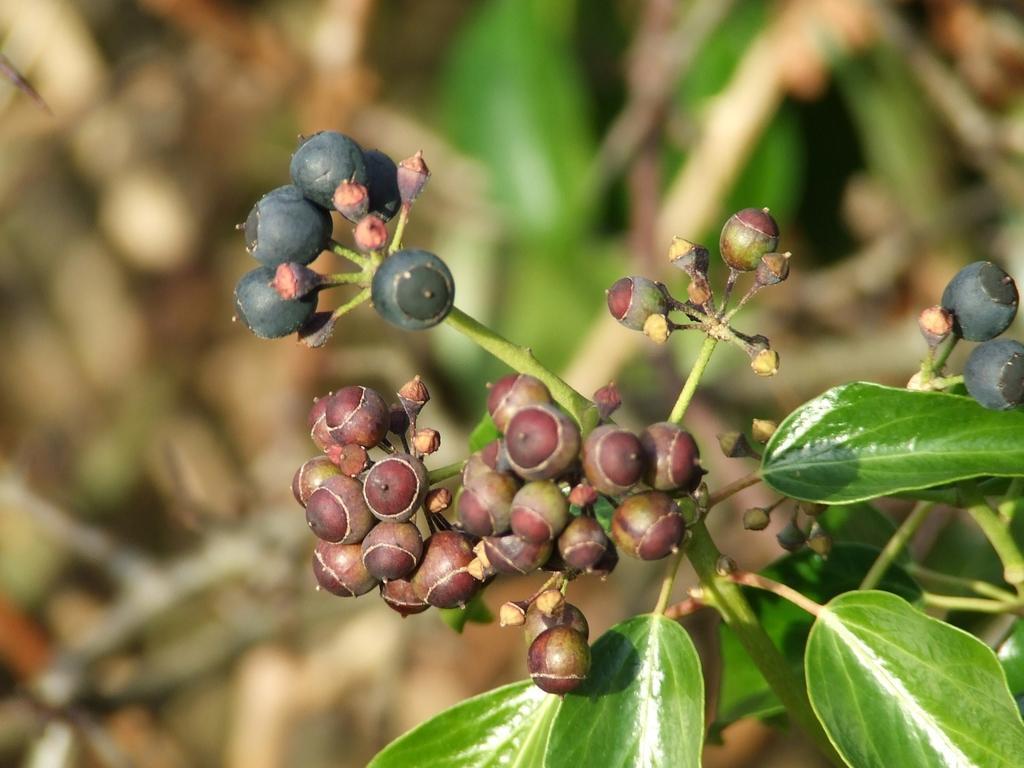Can you describe this image briefly? In the center of the image we can see some fruits, leaves. In the background the image is blur. 